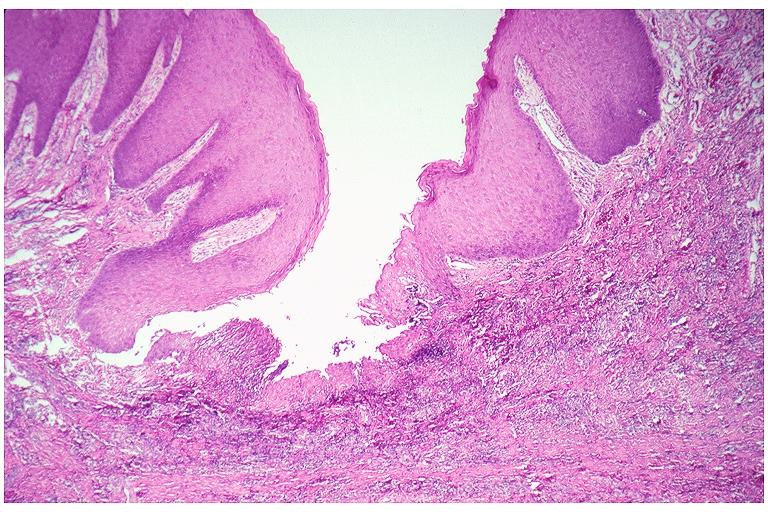s oral present?
Answer the question using a single word or phrase. Yes 